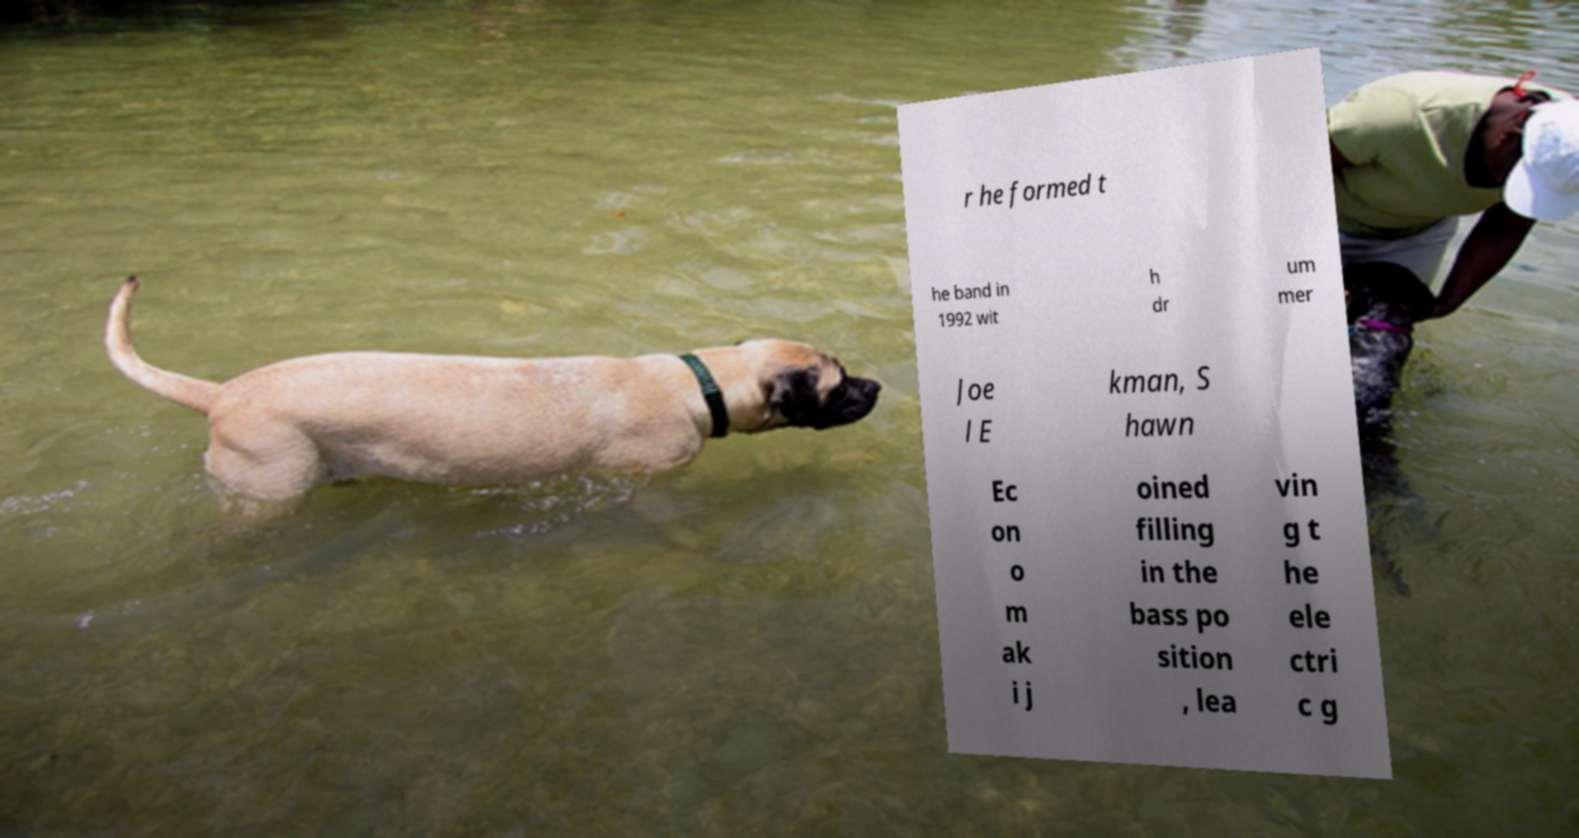There's text embedded in this image that I need extracted. Can you transcribe it verbatim? r he formed t he band in 1992 wit h dr um mer Joe l E kman, S hawn Ec on o m ak i j oined filling in the bass po sition , lea vin g t he ele ctri c g 